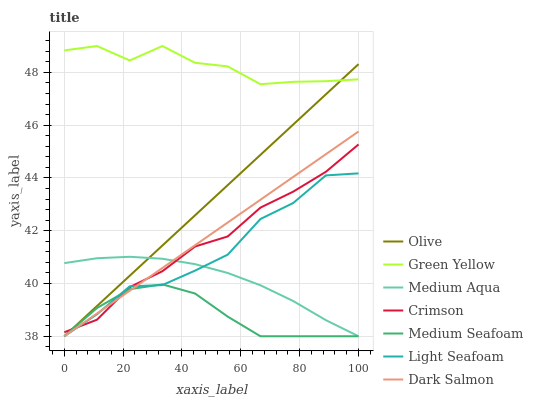Does Medium Seafoam have the minimum area under the curve?
Answer yes or no. Yes. Does Green Yellow have the maximum area under the curve?
Answer yes or no. Yes. Does Dark Salmon have the minimum area under the curve?
Answer yes or no. No. Does Dark Salmon have the maximum area under the curve?
Answer yes or no. No. Is Olive the smoothest?
Answer yes or no. Yes. Is Green Yellow the roughest?
Answer yes or no. Yes. Is Dark Salmon the smoothest?
Answer yes or no. No. Is Dark Salmon the roughest?
Answer yes or no. No. Does Light Seafoam have the lowest value?
Answer yes or no. Yes. Does Crimson have the lowest value?
Answer yes or no. No. Does Green Yellow have the highest value?
Answer yes or no. Yes. Does Dark Salmon have the highest value?
Answer yes or no. No. Is Light Seafoam less than Green Yellow?
Answer yes or no. Yes. Is Green Yellow greater than Crimson?
Answer yes or no. Yes. Does Medium Aqua intersect Olive?
Answer yes or no. Yes. Is Medium Aqua less than Olive?
Answer yes or no. No. Is Medium Aqua greater than Olive?
Answer yes or no. No. Does Light Seafoam intersect Green Yellow?
Answer yes or no. No. 